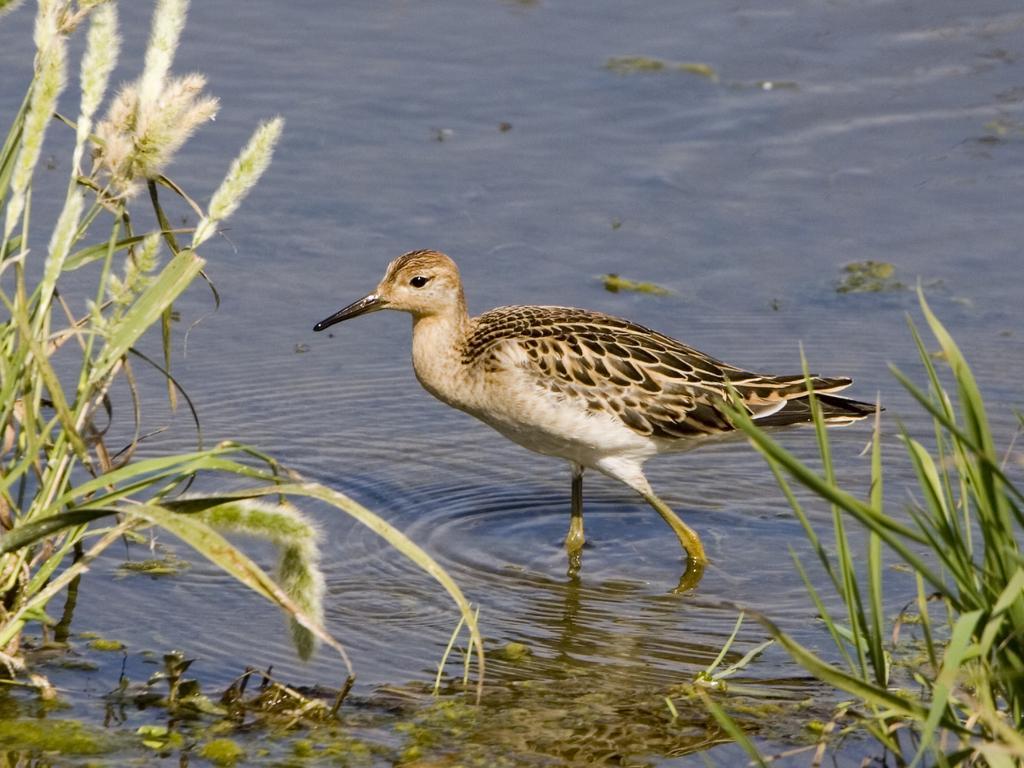How would you summarize this image in a sentence or two? In this image there is a common sandpiper bird in the water, beside the bird there is grass. 